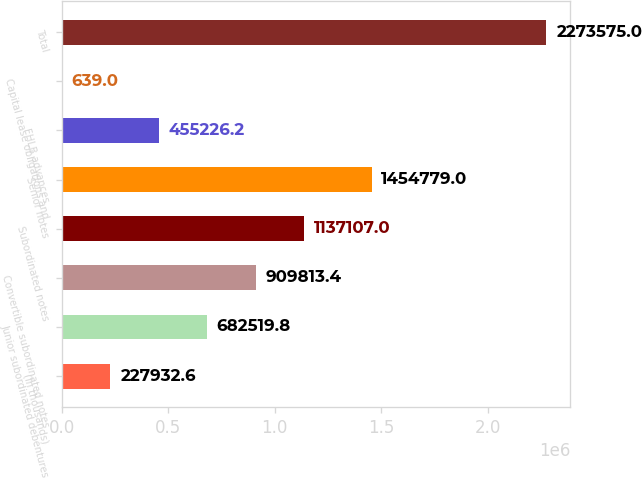Convert chart to OTSL. <chart><loc_0><loc_0><loc_500><loc_500><bar_chart><fcel>(In thousands)<fcel>Junior subordinated debentures<fcel>Convertible subordinated notes<fcel>Subordinated notes<fcel>Senior notes<fcel>FHLB advances<fcel>Capital lease obligations and<fcel>Total<nl><fcel>227933<fcel>682520<fcel>909813<fcel>1.13711e+06<fcel>1.45478e+06<fcel>455226<fcel>639<fcel>2.27358e+06<nl></chart> 